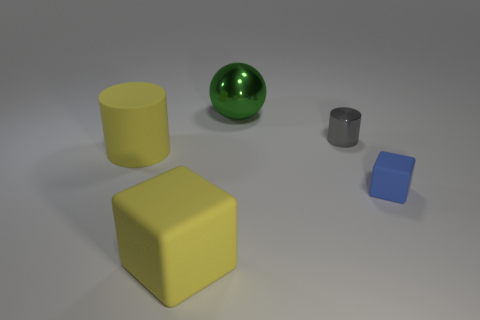Add 5 large brown rubber balls. How many objects exist? 10 Subtract all balls. How many objects are left? 4 Add 4 green spheres. How many green spheres exist? 5 Subtract 0 blue balls. How many objects are left? 5 Subtract all large objects. Subtract all small gray blocks. How many objects are left? 2 Add 1 green balls. How many green balls are left? 2 